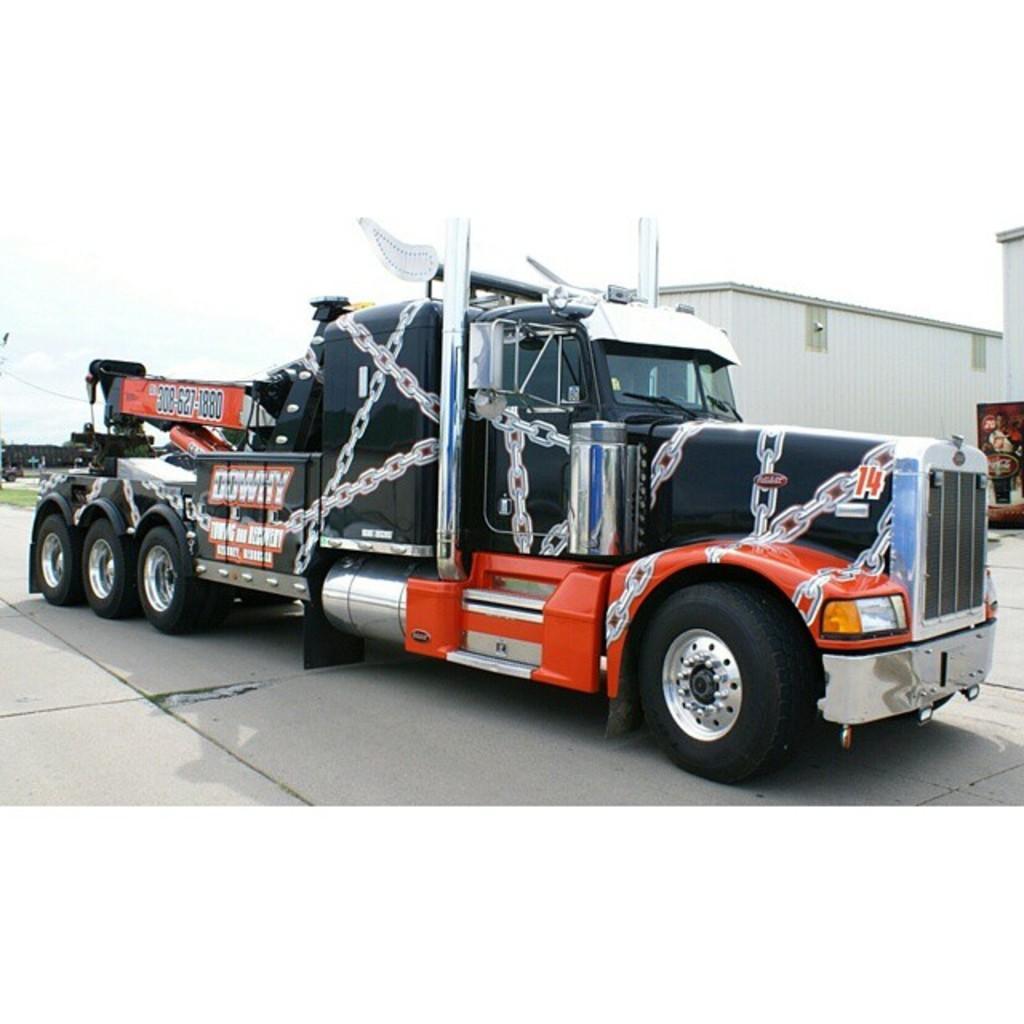Could you give a brief overview of what you see in this image? In this picture I can see a truck, few buildings and trees in the back and a cloudy sky. 